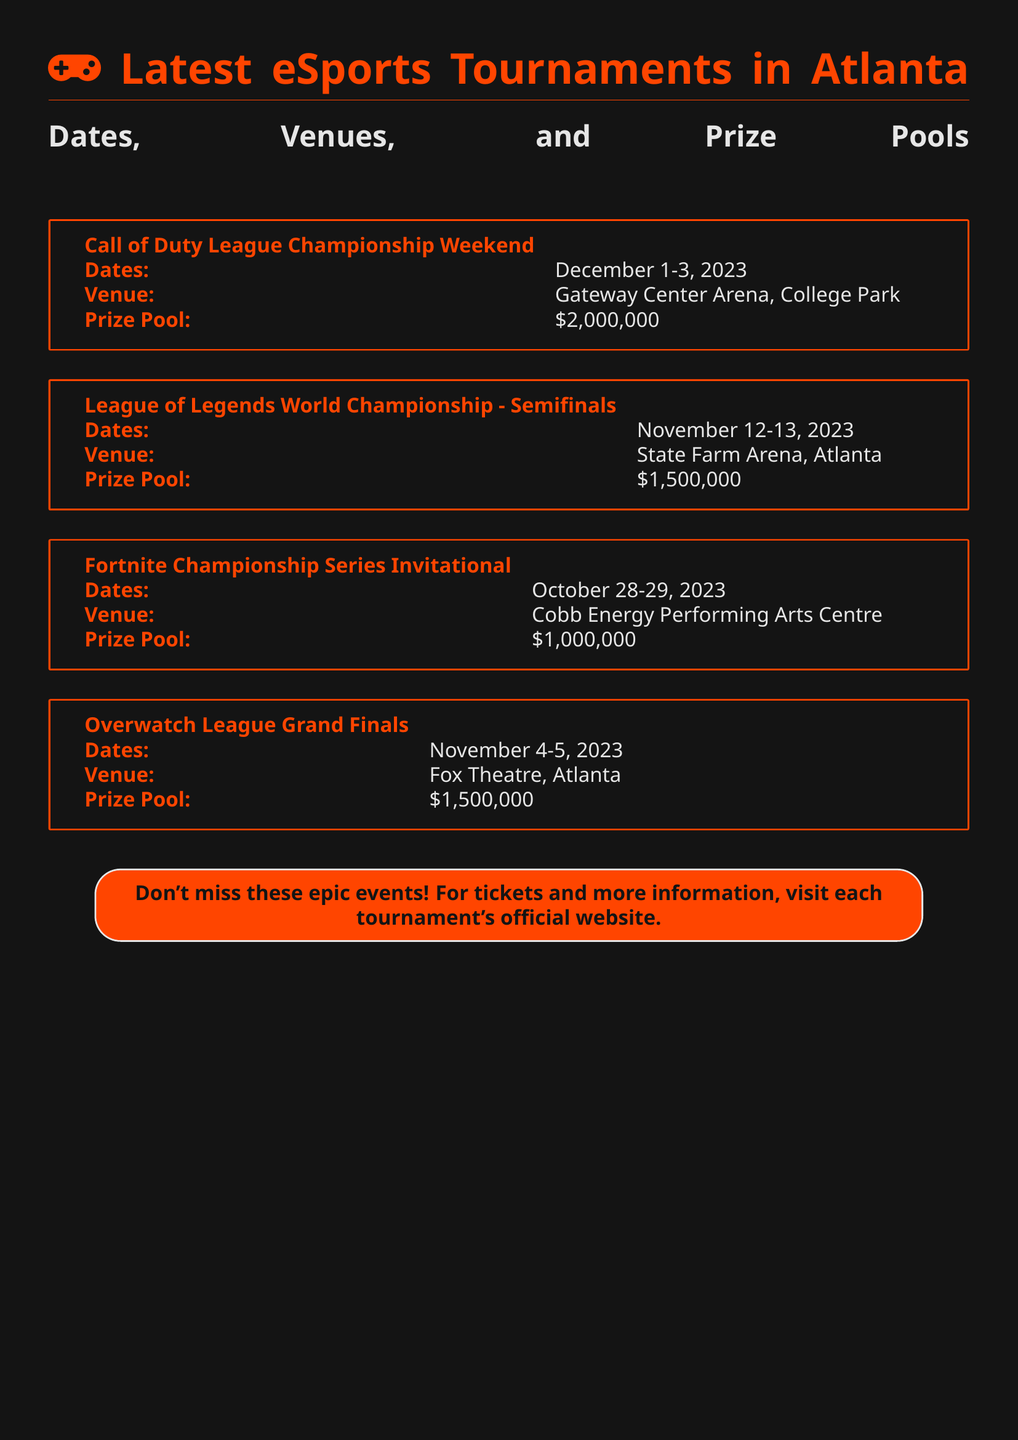What are the dates for the Overwatch League Grand Finals? The Overwatch League Grand Finals are held on November 4-5, 2023 as stated in the document.
Answer: November 4-5, 2023 Where is the League of Legends World Championship Semifinals being held? The venue for the League of Legends World Championship Semifinals is State Farm Arena, Atlanta according to the document.
Answer: State Farm Arena, Atlanta What is the prize pool for the Fortnite Championship Series Invitational? The prize pool for the Fortnite Championship Series Invitational is \$1,000,000 as mentioned in the document.
Answer: \$1,000,000 Which tournament has the highest prize pool? The Call of Duty League Championship Weekend has the highest prize pool of \$2,000,000, which is the largest among all listed tournaments in the document.
Answer: \$2,000,000 How many tournaments are listed in the document? There are four tournaments listed in the document, each with specified dates, venues, and prize pools.
Answer: 4 